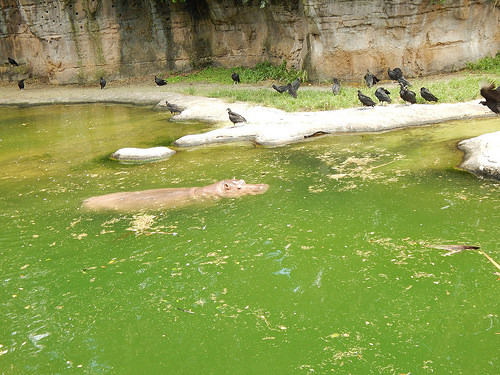<image>
Can you confirm if the hippo is under the water? Yes. The hippo is positioned underneath the water, with the water above it in the vertical space. Where is the bird in relation to the water? Is it in the water? No. The bird is not contained within the water. These objects have a different spatial relationship. 